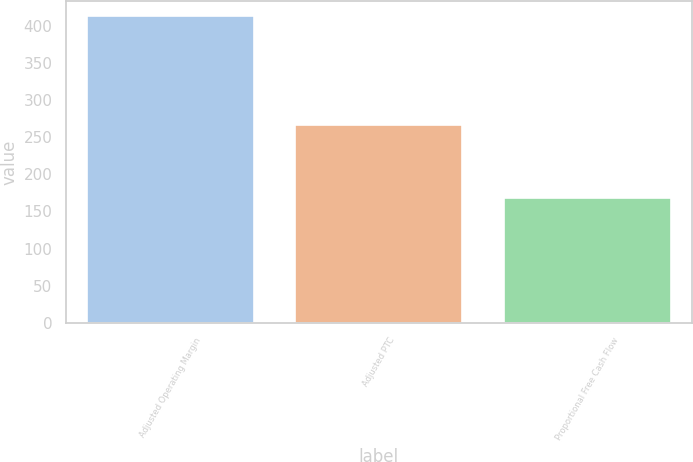<chart> <loc_0><loc_0><loc_500><loc_500><bar_chart><fcel>Adjusted Operating Margin<fcel>Adjusted PTC<fcel>Proportional Free Cash Flow<nl><fcel>413<fcel>267<fcel>168<nl></chart> 